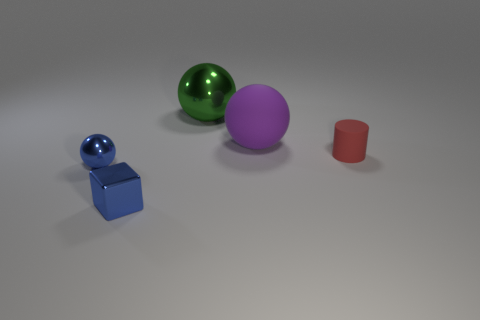What number of rubber things are either yellow cylinders or green things?
Offer a terse response. 0. There is a metal sphere right of the tiny blue thing in front of the blue metal ball; is there a red object on the left side of it?
Keep it short and to the point. No. The small metallic ball is what color?
Provide a short and direct response. Blue. Is the shape of the big object that is to the left of the big purple object the same as  the big purple object?
Offer a very short reply. Yes. How many things are either large matte spheres or matte objects that are on the left side of the matte cylinder?
Ensure brevity in your answer.  1. Do the large thing to the left of the big rubber thing and the tiny ball have the same material?
Provide a succinct answer. Yes. Is there anything else that is the same size as the blue metal ball?
Your response must be concise. Yes. What is the material of the big purple sphere that is behind the tiny blue object that is behind the tiny cube?
Your answer should be very brief. Rubber. Is the number of small rubber cylinders that are in front of the small block greater than the number of cubes that are right of the tiny rubber cylinder?
Your answer should be very brief. No. What size is the purple rubber ball?
Offer a very short reply. Large. 